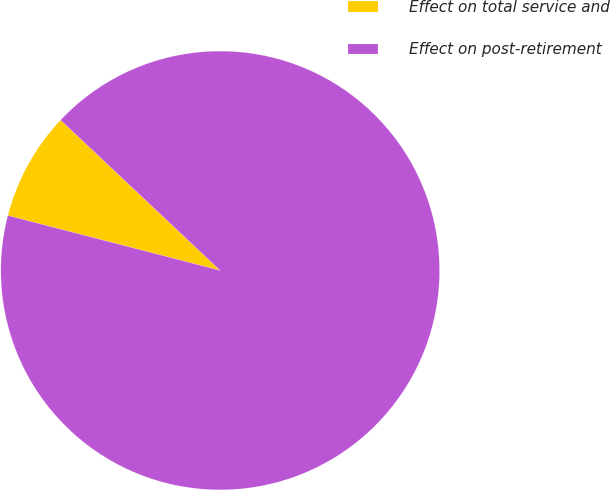<chart> <loc_0><loc_0><loc_500><loc_500><pie_chart><fcel>Effect on total service and<fcel>Effect on post-retirement<nl><fcel>8.0%<fcel>92.0%<nl></chart> 